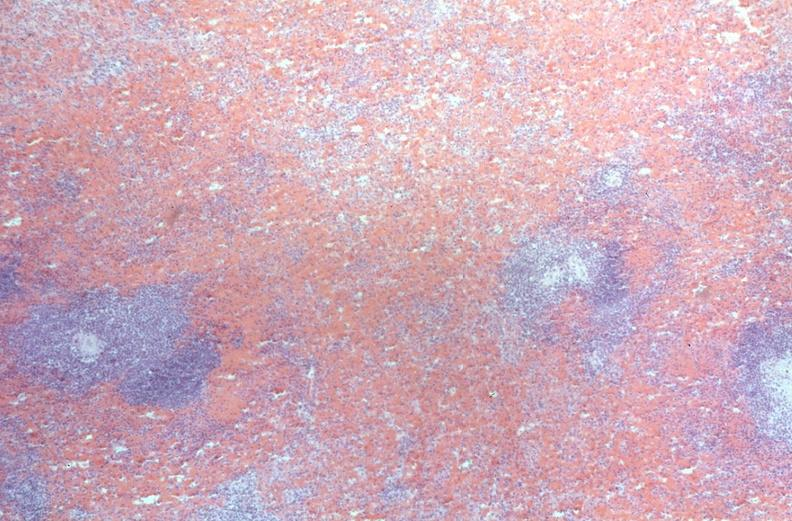what does this image show?
Answer the question using a single word or phrase. Spleen 